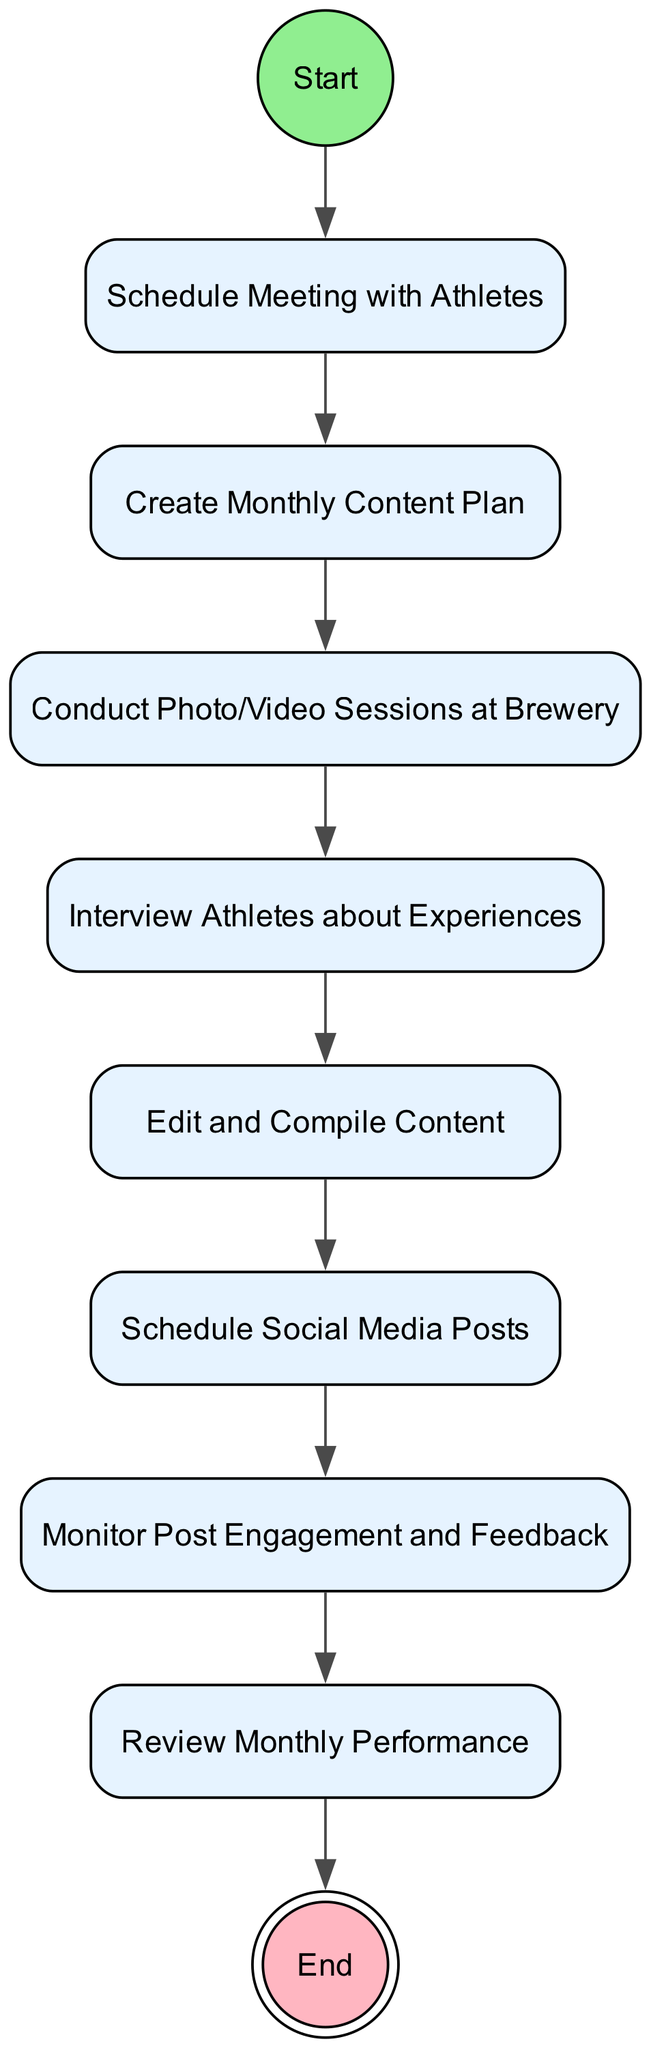What is the starting point of the activity diagram? The starting point of the diagram is represented by the node labeled "Start". This node serves as the initial action before any other activities are carried out.
Answer: Start How many action nodes are present in the diagram? By counting all nodes that are of type "action", we find there are eight action nodes in total. These nodes are related to scheduling, creating content, conducting sessions, editing, and posting for social media.
Answer: 8 What is the last action before the process ends? The last action before reaching the end of the diagram is "Review Monthly Performance". This action is the final activity before moving to the end node.
Answer: Review Monthly Performance Which node follows "Conduct Photo/Video Sessions at Brewery"? The node that follows "Conduct Photo/Video Sessions at Brewery" is "Interview Athletes about Experiences". This indicates that interviewing comes directly after conducting photo/video sessions.
Answer: Interview Athletes about Experiences What type of diagram is represented? This diagram is an "Activity Diagram", which is used to represent the flow of actions or activities in a process. It visually outlines the sequence of actions that are taken.
Answer: Activity Diagram What is the purpose of the "Monitor Post Engagement and Feedback" action? The purpose of "Monitor Post Engagement and Feedback" is to assess how well the scheduled social media posts are performing and to gather feedback from the audience, which helps in evaluating success.
Answer: Assess post performance How does the diagram end? The diagram ends at the node labeled "End", which signifies the completion of the entire process after all actions have been performed and evaluated.
Answer: End Which node comes directly after "Edit and Compile Content"? The node that comes directly after "Edit and Compile Content" is "Schedule Social Media Posts". This indicates the flow from editing content to scheduling it for posting.
Answer: Schedule Social Media Posts What is the relationship between "Schedule Meeting with Athletes" and "Create Monthly Content Plan"? The relationship is sequential; "Schedule Meeting with Athletes" must be completed before "Create Monthly Content Plan" can begin, indicating that the meeting is a prerequisite for planning content.
Answer: Sequential relationship 